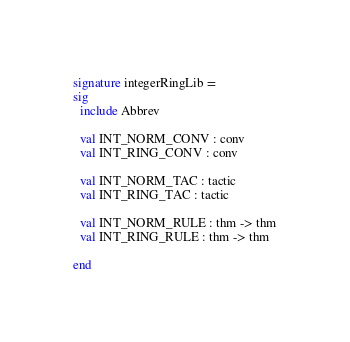<code> <loc_0><loc_0><loc_500><loc_500><_SML_>signature integerRingLib =
sig
  include Abbrev

  val INT_NORM_CONV : conv
  val INT_RING_CONV : conv

  val INT_NORM_TAC : tactic
  val INT_RING_TAC : tactic

  val INT_NORM_RULE : thm -> thm
  val INT_RING_RULE : thm -> thm

end
</code> 